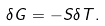<formula> <loc_0><loc_0><loc_500><loc_500>\delta G = - S \delta T .</formula> 